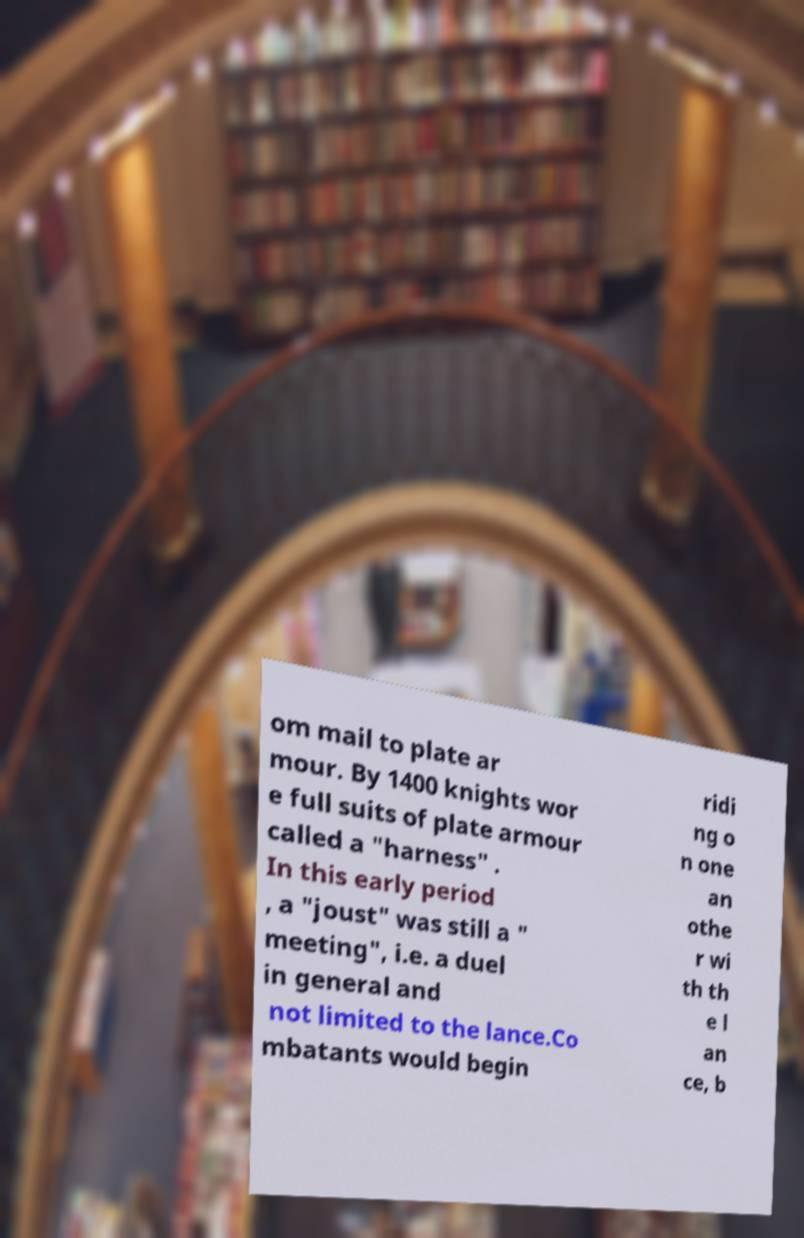Could you assist in decoding the text presented in this image and type it out clearly? om mail to plate ar mour. By 1400 knights wor e full suits of plate armour called a "harness" . In this early period , a "joust" was still a " meeting", i.e. a duel in general and not limited to the lance.Co mbatants would begin ridi ng o n one an othe r wi th th e l an ce, b 